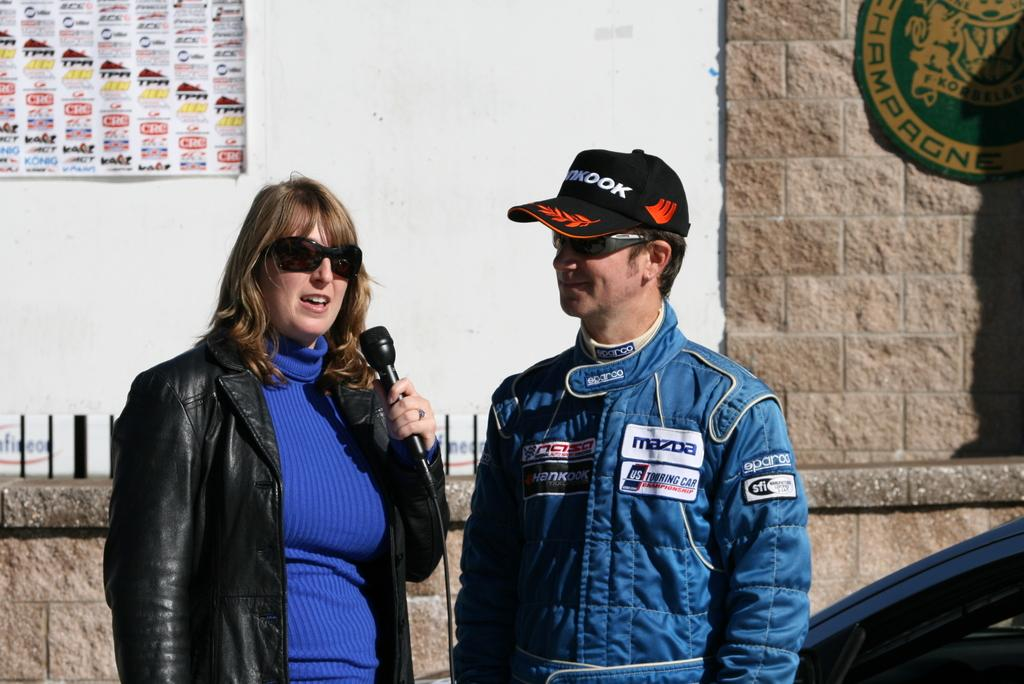<image>
Render a clear and concise summary of the photo. A woman with a microphone talks to a race car driver wearing a MAZDA sponsor patch on his jacket. 